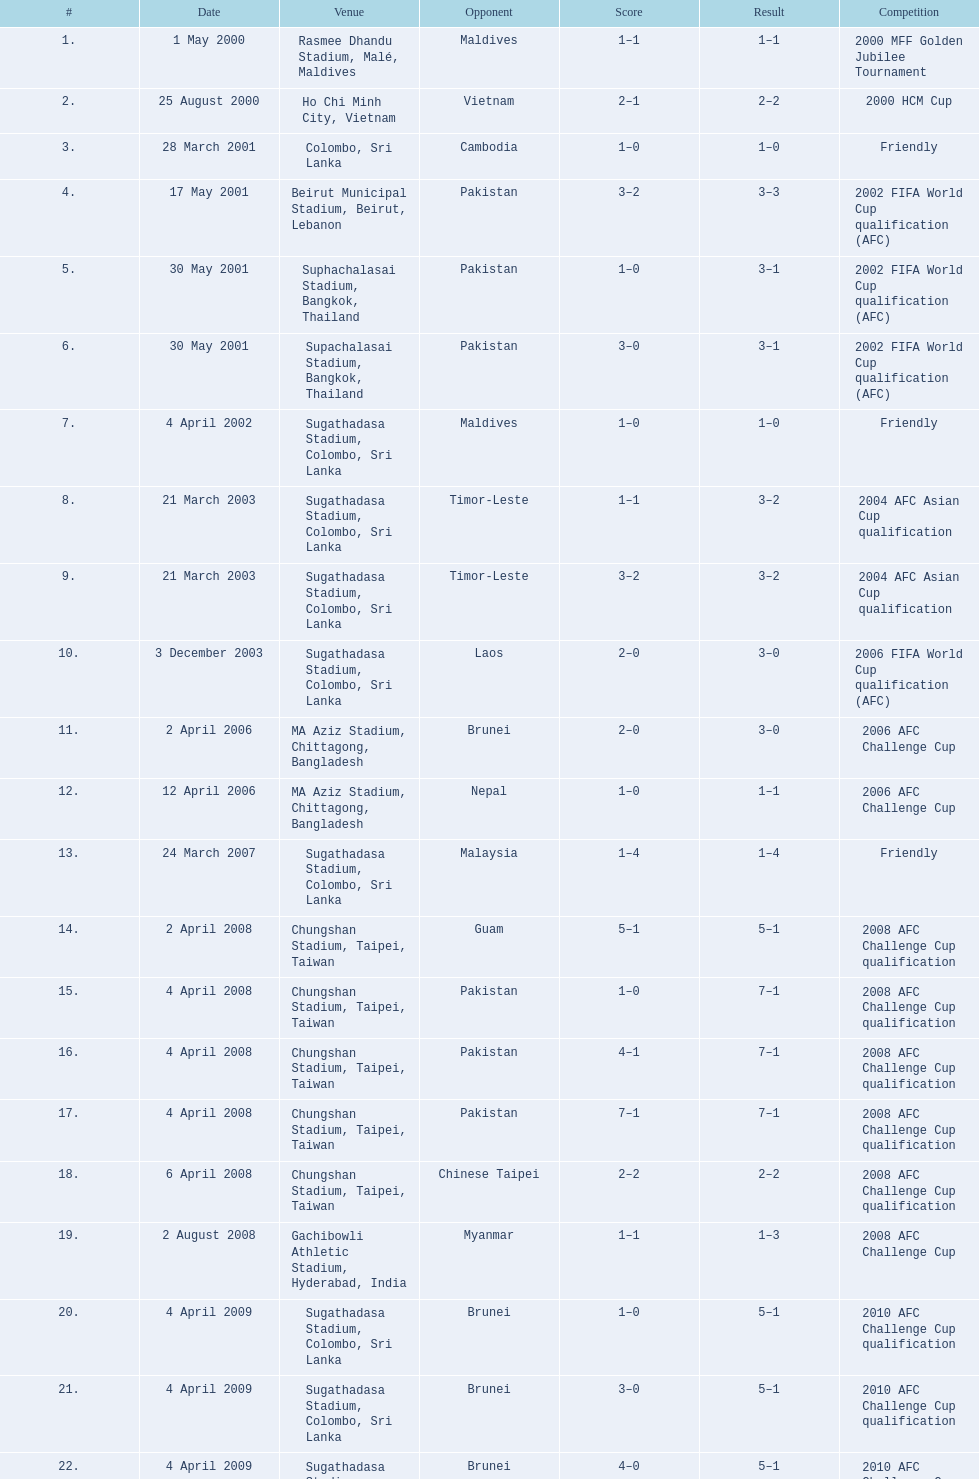In how many games did sri lanka score at least 2 goals? 16. 